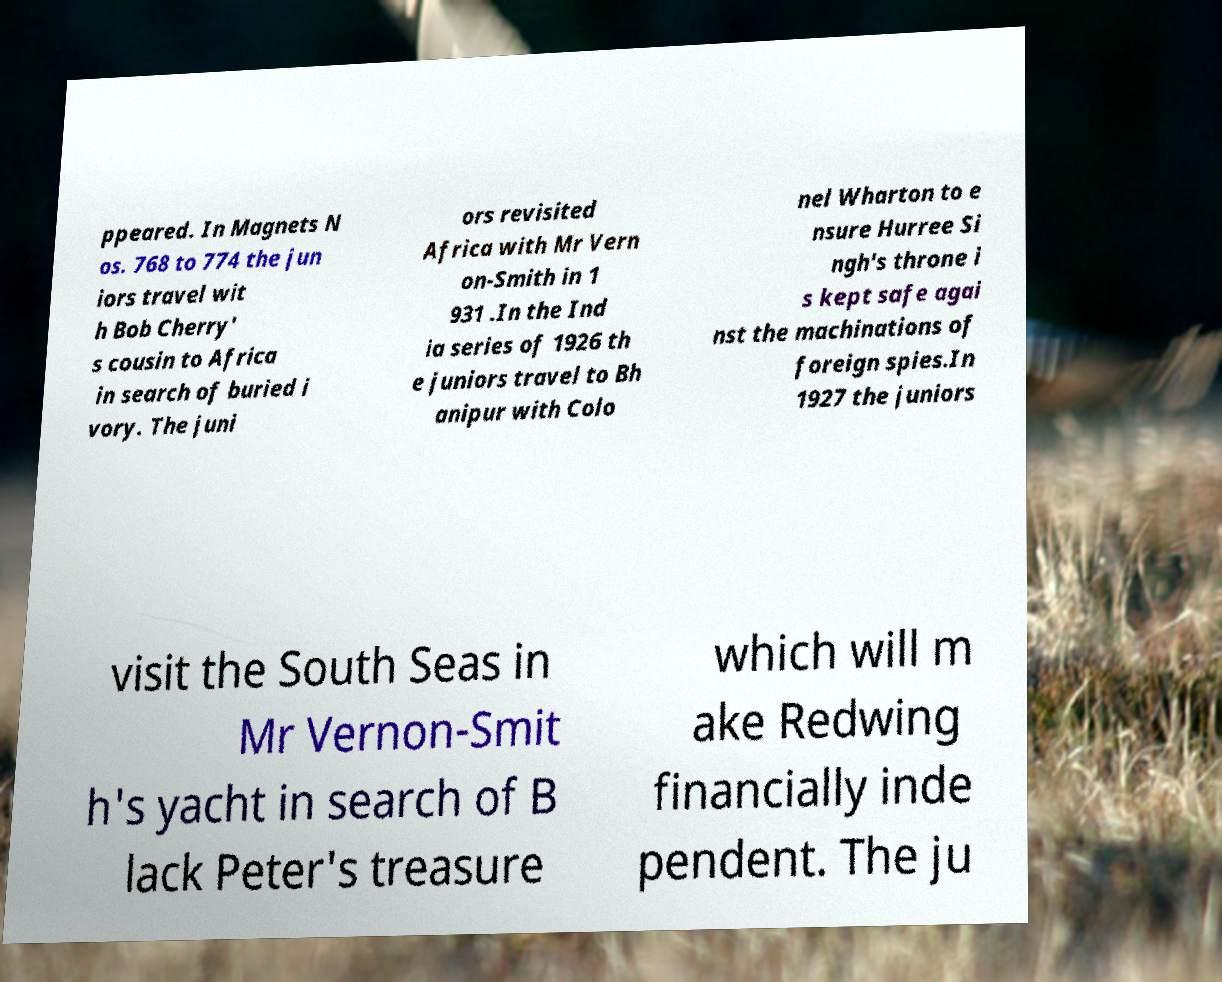There's text embedded in this image that I need extracted. Can you transcribe it verbatim? ppeared. In Magnets N os. 768 to 774 the jun iors travel wit h Bob Cherry' s cousin to Africa in search of buried i vory. The juni ors revisited Africa with Mr Vern on-Smith in 1 931 .In the Ind ia series of 1926 th e juniors travel to Bh anipur with Colo nel Wharton to e nsure Hurree Si ngh's throne i s kept safe agai nst the machinations of foreign spies.In 1927 the juniors visit the South Seas in Mr Vernon-Smit h's yacht in search of B lack Peter's treasure which will m ake Redwing financially inde pendent. The ju 